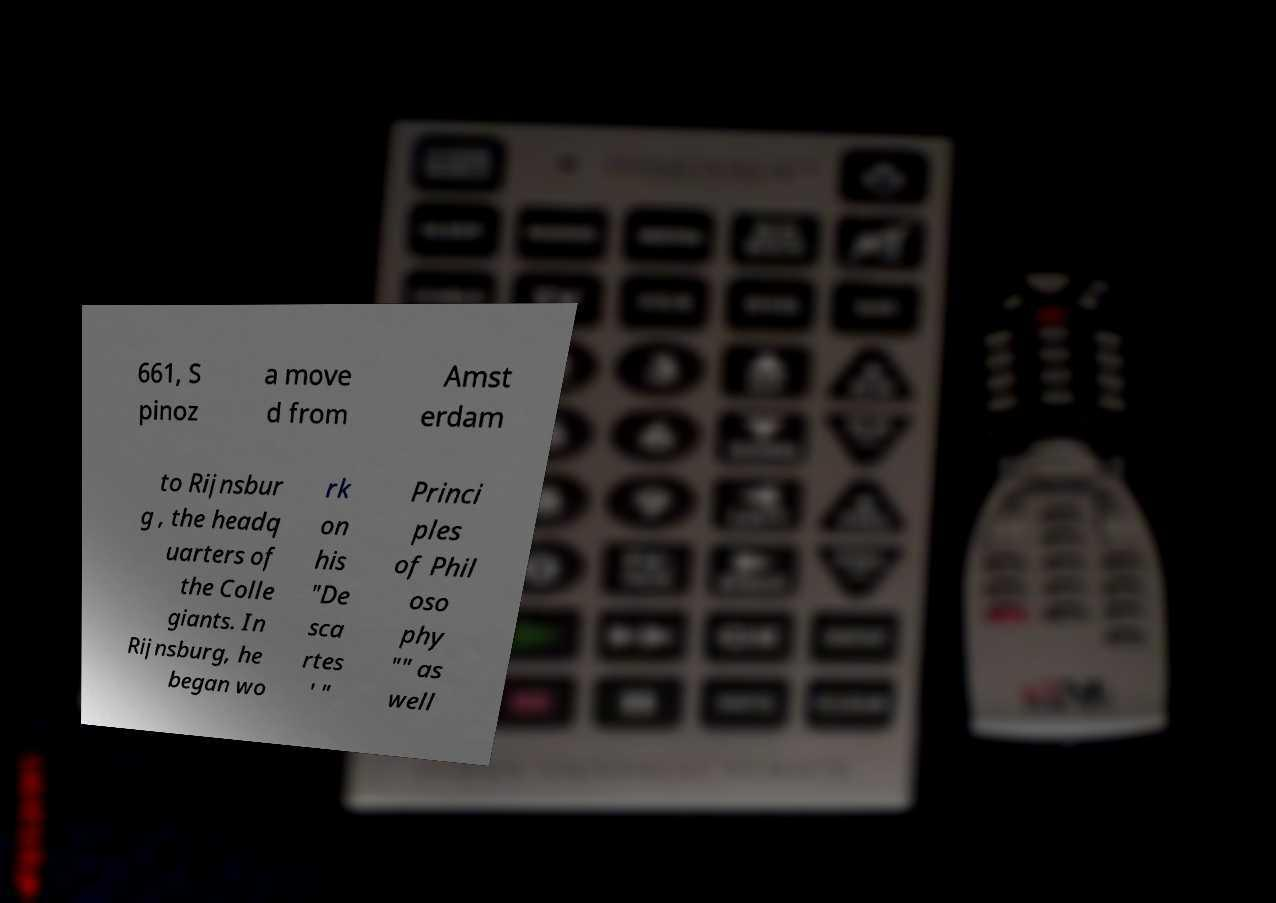Can you read and provide the text displayed in the image?This photo seems to have some interesting text. Can you extract and type it out for me? 661, S pinoz a move d from Amst erdam to Rijnsbur g , the headq uarters of the Colle giants. In Rijnsburg, he began wo rk on his "De sca rtes ' " Princi ples of Phil oso phy "" as well 